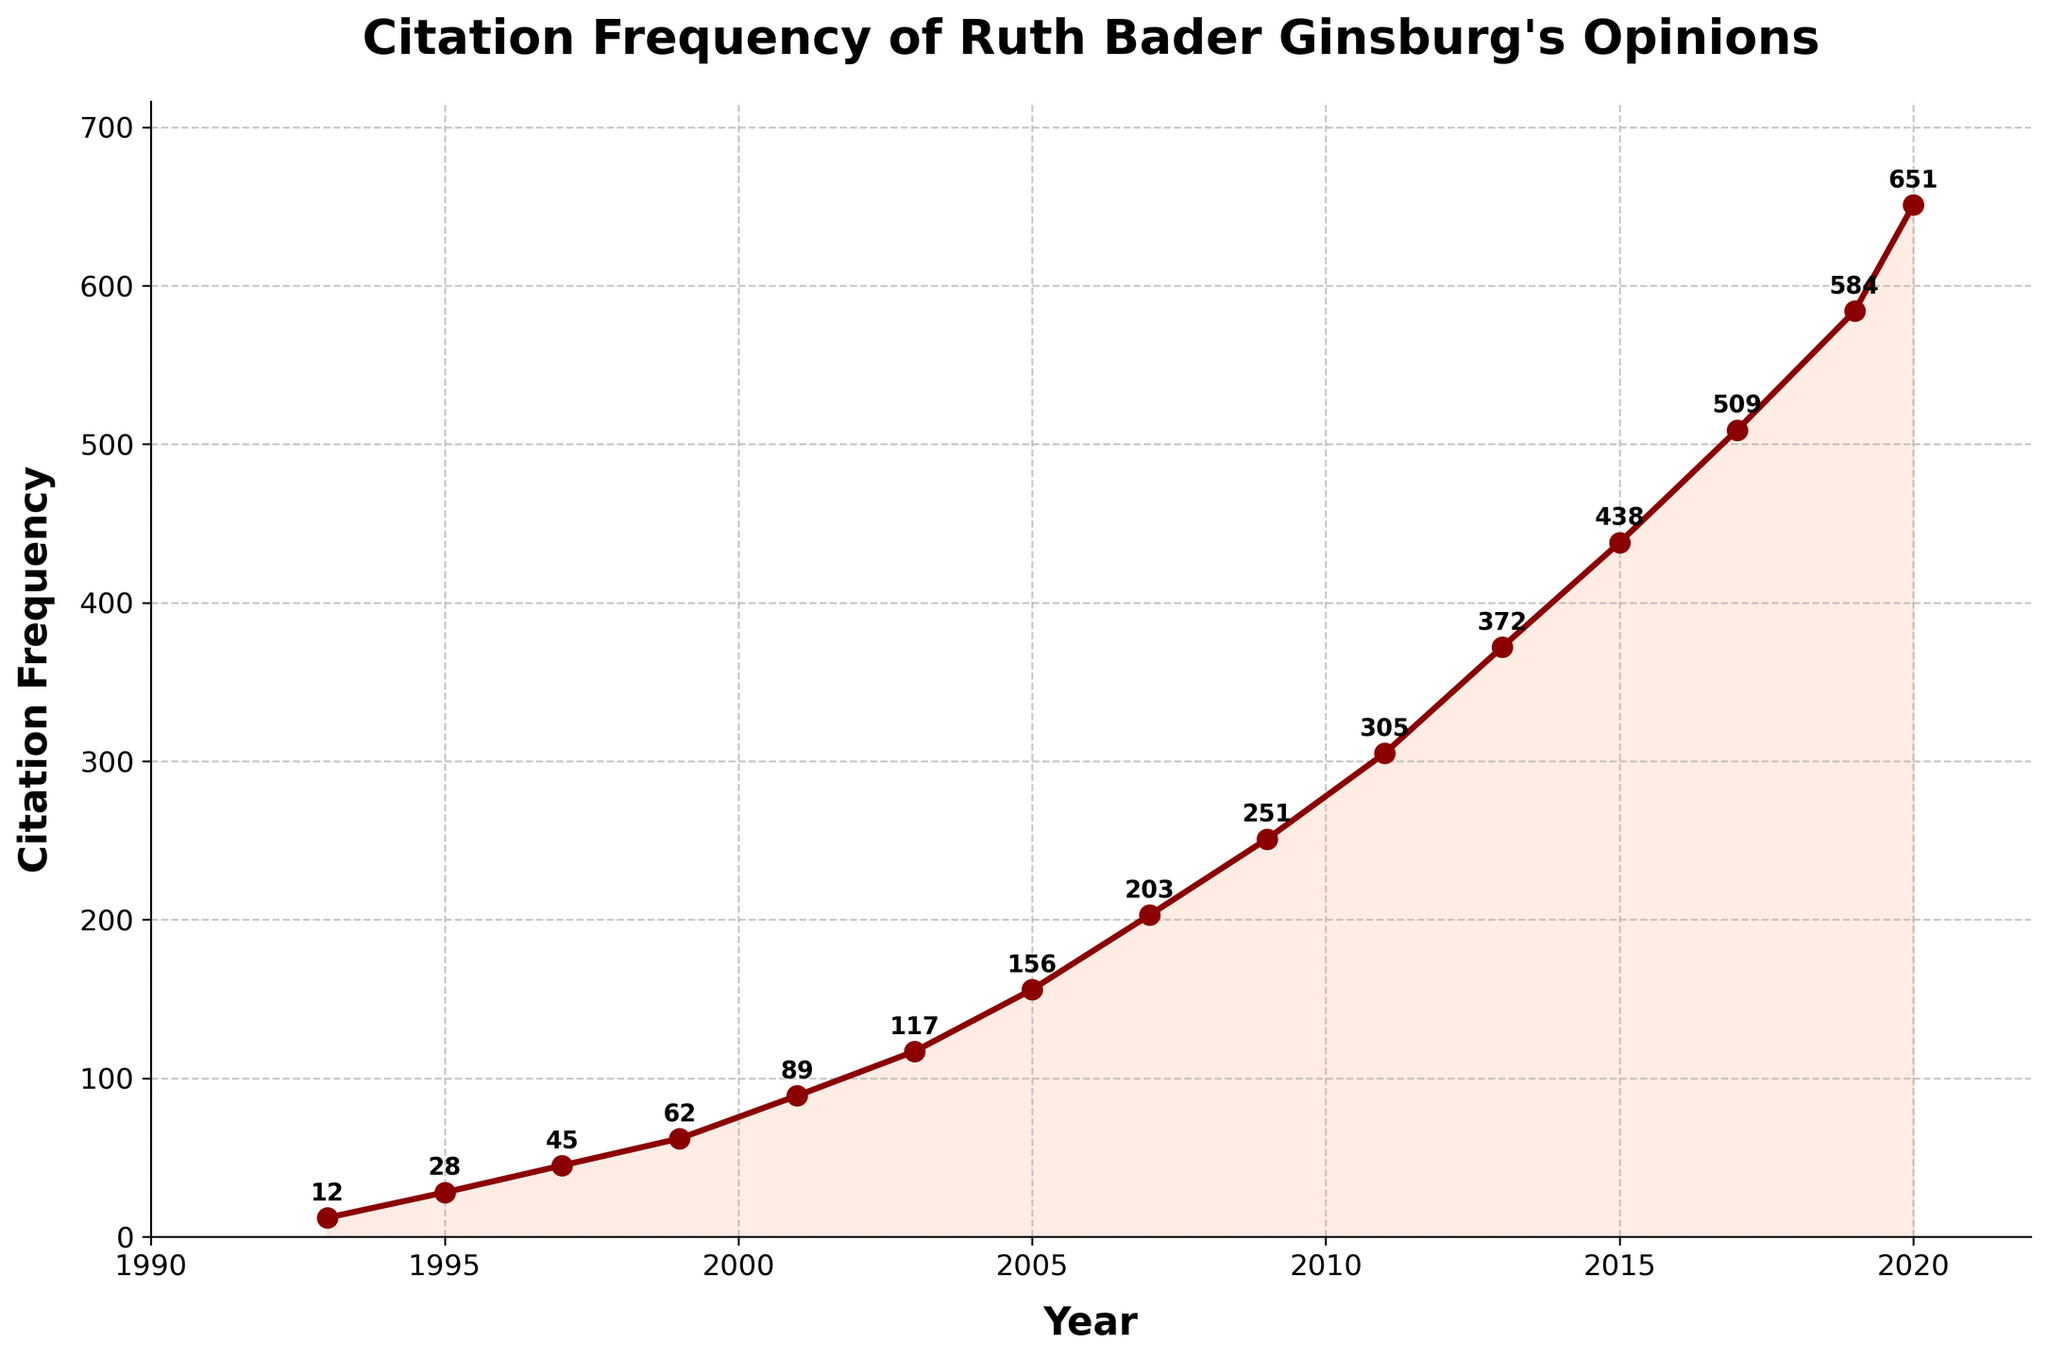What was the citation frequency in 1999? To determine the citation frequency in 1999, locate the data point on the line chart corresponding to the year 1999. The citation frequency value next to this point is the answer.
Answer: 62 How much did the citation frequency increase from 1995 to 2001? First, identify the citation frequencies for 1995 and 2001 from the chart, which are 28 and 89 respectively. Then, subtract the former from the latter: 89 - 28 = 61.
Answer: 61 Which year saw the highest increase in citation frequency? Look at the steepness of the line segments between each consecutive pair of years. The segment from 2019 to 2020 shows the steepest increase, indicating the highest rise in citations.
Answer: 2019 to 2020 What is the average citation frequency from 1993 to 2020? Sum up the citation frequencies from 1993 (12) to 2020 (651) and then divide by the number of years (15). The sum is 3282, so the average is 3282/15 = 218.8.
Answer: 218.8 Compare the citation frequencies in 2001 and 2007. Which year had more citations? Identify the citation frequencies in 2001 and 2007 from the chart, which are 89 and 203 respectively. Since 203 is greater than 89, 2007 had more citations.
Answer: 2007 What is the ratio of citation frequencies between the years 2011 and 2015? Identify the citation frequencies for 2011 (305) and 2015 (438). The ratio of 2011 to 2015 is 305/438, which simplifies approximately to 0.70.
Answer: 0.70 What is the median citation frequency over the years presented in the chart? List the citation frequencies in ascending order and find the middle value. The frequencies are: 12, 28, 45, 62, 89, 117, 156, 203, 251, 305, 372, 438, 509, 584, 651. The median is the 8th value in this ordered list, which is 203.
Answer: 203 How did the citation frequency change from 2005 to 2009? Identify the citation frequencies for 2005 and 2009 from the chart, which are 156 and 251. Calculate the difference: 251 - 156 = 95. So, the citation frequency increased by 95.
Answer: 95 Between which consecutive years did the citation frequency grow the least? Compare the differences in citation frequencies between consecutive years. The smallest increase appears between 2015 (438) and 2017 (509) which is 509 - 438 = 71.
Answer: 2015 to 2017 In what year did the citation frequency first exceed 500? Identify the data points where the citation frequency surpasses 500. The frequency in 2017 is 509, so 2017 is the first year it exceeded 500.
Answer: 2017 